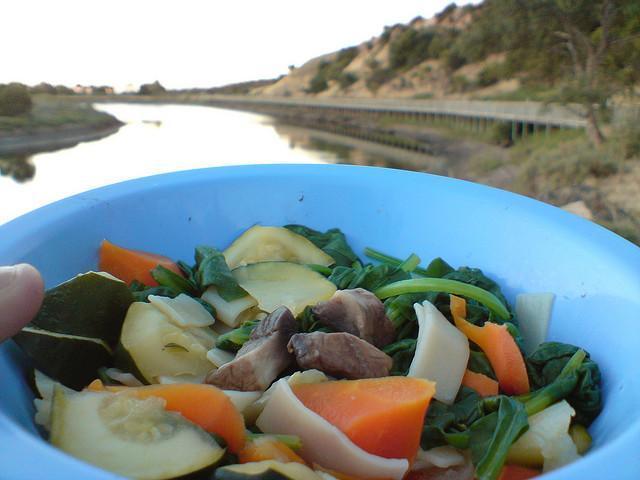How many carrots are there?
Give a very brief answer. 4. 